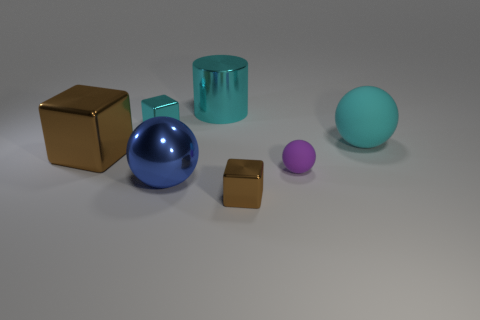There is a block that is both on the right side of the large brown block and behind the small purple sphere; what size is it?
Provide a short and direct response. Small. Are there any shiny blocks that are to the right of the tiny shiny block on the left side of the big ball that is in front of the big brown shiny block?
Give a very brief answer. Yes. Is there a blue shiny ball?
Your response must be concise. Yes. Is the number of things that are behind the large blue thing greater than the number of small cyan things that are in front of the purple rubber thing?
Make the answer very short. Yes. There is a purple thing that is made of the same material as the cyan sphere; what size is it?
Keep it short and to the point. Small. What size is the purple rubber thing that is behind the brown metallic thing right of the tiny cube behind the small brown metal block?
Offer a very short reply. Small. What is the color of the tiny metallic object that is in front of the big brown object?
Your answer should be very brief. Brown. Are there more balls that are behind the big blue sphere than big purple matte blocks?
Your response must be concise. Yes. Do the large object that is left of the large blue metal thing and the small purple rubber object have the same shape?
Provide a short and direct response. No. How many cyan things are either big metallic cylinders or tiny rubber objects?
Offer a very short reply. 1. 